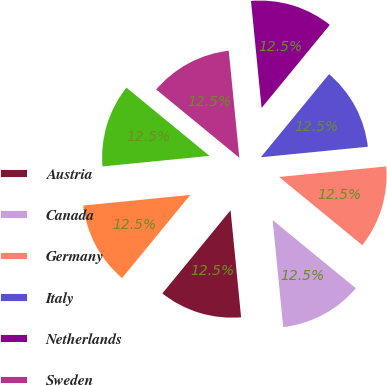Convert chart to OTSL. <chart><loc_0><loc_0><loc_500><loc_500><pie_chart><fcel>Austria<fcel>Canada<fcel>Germany<fcel>Italy<fcel>Netherlands<fcel>Sweden<fcel>United Kingdom<fcel>United States<nl><fcel>12.5%<fcel>12.51%<fcel>12.49%<fcel>12.5%<fcel>12.51%<fcel>12.49%<fcel>12.51%<fcel>12.5%<nl></chart> 